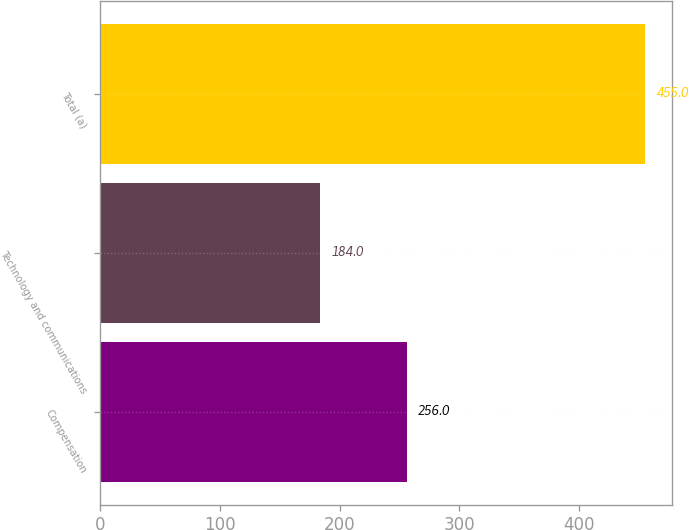Convert chart to OTSL. <chart><loc_0><loc_0><loc_500><loc_500><bar_chart><fcel>Compensation<fcel>Technology and communications<fcel>Total (a)<nl><fcel>256<fcel>184<fcel>455<nl></chart> 